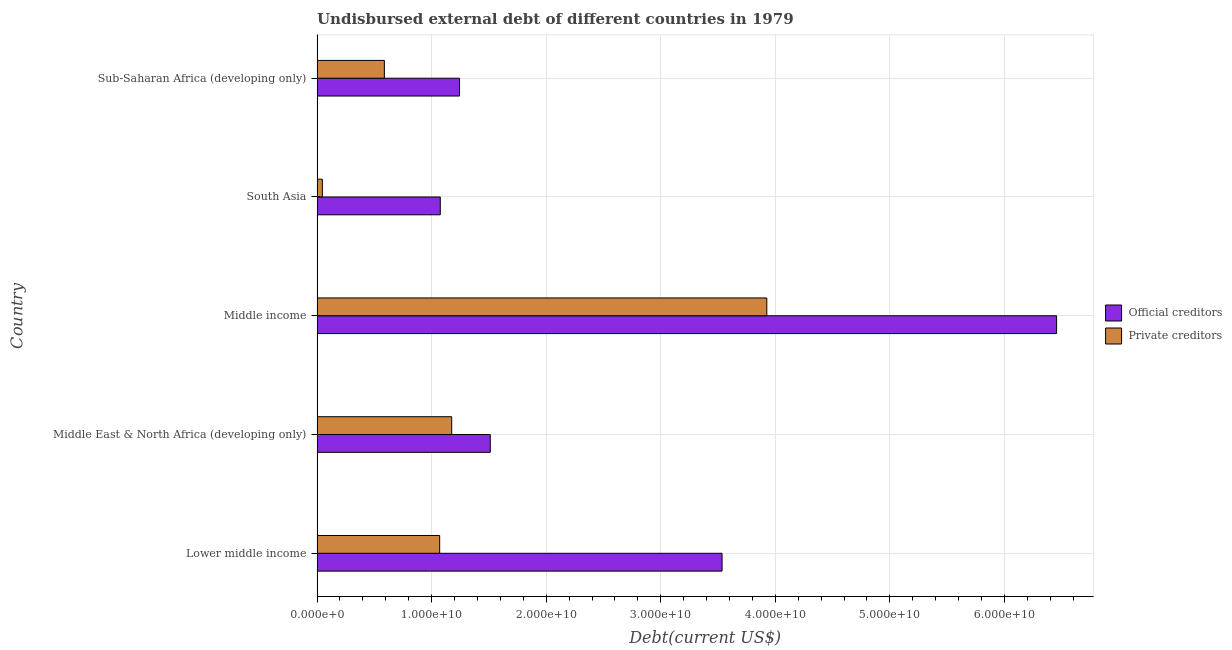How many different coloured bars are there?
Ensure brevity in your answer.  2. How many groups of bars are there?
Ensure brevity in your answer.  5. What is the label of the 1st group of bars from the top?
Your answer should be very brief. Sub-Saharan Africa (developing only). What is the undisbursed external debt of official creditors in Middle income?
Keep it short and to the point. 6.46e+1. Across all countries, what is the maximum undisbursed external debt of private creditors?
Your answer should be compact. 3.93e+1. Across all countries, what is the minimum undisbursed external debt of private creditors?
Your response must be concise. 4.63e+08. What is the total undisbursed external debt of private creditors in the graph?
Your answer should be very brief. 6.81e+1. What is the difference between the undisbursed external debt of private creditors in Lower middle income and that in South Asia?
Provide a succinct answer. 1.02e+1. What is the difference between the undisbursed external debt of private creditors in Sub-Saharan Africa (developing only) and the undisbursed external debt of official creditors in Middle East & North Africa (developing only)?
Provide a short and direct response. -9.24e+09. What is the average undisbursed external debt of private creditors per country?
Offer a very short reply. 1.36e+1. What is the difference between the undisbursed external debt of official creditors and undisbursed external debt of private creditors in Lower middle income?
Offer a very short reply. 2.46e+1. What is the ratio of the undisbursed external debt of official creditors in Middle income to that in South Asia?
Make the answer very short. 6. Is the undisbursed external debt of official creditors in Middle East & North Africa (developing only) less than that in Sub-Saharan Africa (developing only)?
Your answer should be very brief. No. What is the difference between the highest and the second highest undisbursed external debt of private creditors?
Give a very brief answer. 2.75e+1. What is the difference between the highest and the lowest undisbursed external debt of official creditors?
Offer a very short reply. 5.38e+1. In how many countries, is the undisbursed external debt of private creditors greater than the average undisbursed external debt of private creditors taken over all countries?
Keep it short and to the point. 1. Is the sum of the undisbursed external debt of official creditors in Lower middle income and Middle income greater than the maximum undisbursed external debt of private creditors across all countries?
Provide a short and direct response. Yes. What does the 2nd bar from the top in Middle East & North Africa (developing only) represents?
Your answer should be very brief. Official creditors. What does the 2nd bar from the bottom in Lower middle income represents?
Give a very brief answer. Private creditors. How many bars are there?
Give a very brief answer. 10. Are all the bars in the graph horizontal?
Your answer should be compact. Yes. Does the graph contain grids?
Your answer should be compact. Yes. Where does the legend appear in the graph?
Your answer should be very brief. Center right. How are the legend labels stacked?
Offer a very short reply. Vertical. What is the title of the graph?
Make the answer very short. Undisbursed external debt of different countries in 1979. What is the label or title of the X-axis?
Give a very brief answer. Debt(current US$). What is the Debt(current US$) of Official creditors in Lower middle income?
Offer a very short reply. 3.54e+1. What is the Debt(current US$) of Private creditors in Lower middle income?
Ensure brevity in your answer.  1.07e+1. What is the Debt(current US$) of Official creditors in Middle East & North Africa (developing only)?
Your response must be concise. 1.51e+1. What is the Debt(current US$) of Private creditors in Middle East & North Africa (developing only)?
Your answer should be very brief. 1.18e+1. What is the Debt(current US$) in Official creditors in Middle income?
Offer a very short reply. 6.46e+1. What is the Debt(current US$) in Private creditors in Middle income?
Provide a short and direct response. 3.93e+1. What is the Debt(current US$) in Official creditors in South Asia?
Provide a succinct answer. 1.08e+1. What is the Debt(current US$) of Private creditors in South Asia?
Keep it short and to the point. 4.63e+08. What is the Debt(current US$) in Official creditors in Sub-Saharan Africa (developing only)?
Give a very brief answer. 1.24e+1. What is the Debt(current US$) in Private creditors in Sub-Saharan Africa (developing only)?
Your response must be concise. 5.88e+09. Across all countries, what is the maximum Debt(current US$) in Official creditors?
Ensure brevity in your answer.  6.46e+1. Across all countries, what is the maximum Debt(current US$) in Private creditors?
Offer a terse response. 3.93e+1. Across all countries, what is the minimum Debt(current US$) of Official creditors?
Offer a terse response. 1.08e+1. Across all countries, what is the minimum Debt(current US$) of Private creditors?
Give a very brief answer. 4.63e+08. What is the total Debt(current US$) in Official creditors in the graph?
Provide a short and direct response. 1.38e+11. What is the total Debt(current US$) of Private creditors in the graph?
Keep it short and to the point. 6.81e+1. What is the difference between the Debt(current US$) of Official creditors in Lower middle income and that in Middle East & North Africa (developing only)?
Your answer should be very brief. 2.02e+1. What is the difference between the Debt(current US$) in Private creditors in Lower middle income and that in Middle East & North Africa (developing only)?
Provide a short and direct response. -1.05e+09. What is the difference between the Debt(current US$) in Official creditors in Lower middle income and that in Middle income?
Keep it short and to the point. -2.92e+1. What is the difference between the Debt(current US$) of Private creditors in Lower middle income and that in Middle income?
Offer a terse response. -2.86e+1. What is the difference between the Debt(current US$) of Official creditors in Lower middle income and that in South Asia?
Give a very brief answer. 2.46e+1. What is the difference between the Debt(current US$) of Private creditors in Lower middle income and that in South Asia?
Keep it short and to the point. 1.02e+1. What is the difference between the Debt(current US$) of Official creditors in Lower middle income and that in Sub-Saharan Africa (developing only)?
Offer a very short reply. 2.29e+1. What is the difference between the Debt(current US$) in Private creditors in Lower middle income and that in Sub-Saharan Africa (developing only)?
Your answer should be compact. 4.83e+09. What is the difference between the Debt(current US$) of Official creditors in Middle East & North Africa (developing only) and that in Middle income?
Offer a very short reply. -4.94e+1. What is the difference between the Debt(current US$) of Private creditors in Middle East & North Africa (developing only) and that in Middle income?
Your response must be concise. -2.75e+1. What is the difference between the Debt(current US$) of Official creditors in Middle East & North Africa (developing only) and that in South Asia?
Provide a succinct answer. 4.36e+09. What is the difference between the Debt(current US$) in Private creditors in Middle East & North Africa (developing only) and that in South Asia?
Offer a terse response. 1.13e+1. What is the difference between the Debt(current US$) in Official creditors in Middle East & North Africa (developing only) and that in Sub-Saharan Africa (developing only)?
Your response must be concise. 2.68e+09. What is the difference between the Debt(current US$) of Private creditors in Middle East & North Africa (developing only) and that in Sub-Saharan Africa (developing only)?
Your response must be concise. 5.88e+09. What is the difference between the Debt(current US$) in Official creditors in Middle income and that in South Asia?
Offer a terse response. 5.38e+1. What is the difference between the Debt(current US$) of Private creditors in Middle income and that in South Asia?
Provide a succinct answer. 3.88e+1. What is the difference between the Debt(current US$) of Official creditors in Middle income and that in Sub-Saharan Africa (developing only)?
Make the answer very short. 5.21e+1. What is the difference between the Debt(current US$) of Private creditors in Middle income and that in Sub-Saharan Africa (developing only)?
Offer a very short reply. 3.34e+1. What is the difference between the Debt(current US$) of Official creditors in South Asia and that in Sub-Saharan Africa (developing only)?
Your answer should be compact. -1.68e+09. What is the difference between the Debt(current US$) in Private creditors in South Asia and that in Sub-Saharan Africa (developing only)?
Offer a terse response. -5.41e+09. What is the difference between the Debt(current US$) of Official creditors in Lower middle income and the Debt(current US$) of Private creditors in Middle East & North Africa (developing only)?
Your answer should be compact. 2.36e+1. What is the difference between the Debt(current US$) in Official creditors in Lower middle income and the Debt(current US$) in Private creditors in Middle income?
Provide a succinct answer. -3.91e+09. What is the difference between the Debt(current US$) in Official creditors in Lower middle income and the Debt(current US$) in Private creditors in South Asia?
Provide a short and direct response. 3.49e+1. What is the difference between the Debt(current US$) in Official creditors in Lower middle income and the Debt(current US$) in Private creditors in Sub-Saharan Africa (developing only)?
Keep it short and to the point. 2.95e+1. What is the difference between the Debt(current US$) in Official creditors in Middle East & North Africa (developing only) and the Debt(current US$) in Private creditors in Middle income?
Offer a very short reply. -2.41e+1. What is the difference between the Debt(current US$) of Official creditors in Middle East & North Africa (developing only) and the Debt(current US$) of Private creditors in South Asia?
Your response must be concise. 1.47e+1. What is the difference between the Debt(current US$) in Official creditors in Middle East & North Africa (developing only) and the Debt(current US$) in Private creditors in Sub-Saharan Africa (developing only)?
Make the answer very short. 9.24e+09. What is the difference between the Debt(current US$) in Official creditors in Middle income and the Debt(current US$) in Private creditors in South Asia?
Give a very brief answer. 6.41e+1. What is the difference between the Debt(current US$) in Official creditors in Middle income and the Debt(current US$) in Private creditors in Sub-Saharan Africa (developing only)?
Offer a terse response. 5.87e+1. What is the difference between the Debt(current US$) of Official creditors in South Asia and the Debt(current US$) of Private creditors in Sub-Saharan Africa (developing only)?
Make the answer very short. 4.88e+09. What is the average Debt(current US$) in Official creditors per country?
Offer a very short reply. 2.76e+1. What is the average Debt(current US$) in Private creditors per country?
Make the answer very short. 1.36e+1. What is the difference between the Debt(current US$) of Official creditors and Debt(current US$) of Private creditors in Lower middle income?
Your answer should be compact. 2.46e+1. What is the difference between the Debt(current US$) in Official creditors and Debt(current US$) in Private creditors in Middle East & North Africa (developing only)?
Make the answer very short. 3.37e+09. What is the difference between the Debt(current US$) in Official creditors and Debt(current US$) in Private creditors in Middle income?
Your answer should be compact. 2.53e+1. What is the difference between the Debt(current US$) of Official creditors and Debt(current US$) of Private creditors in South Asia?
Give a very brief answer. 1.03e+1. What is the difference between the Debt(current US$) in Official creditors and Debt(current US$) in Private creditors in Sub-Saharan Africa (developing only)?
Your answer should be compact. 6.56e+09. What is the ratio of the Debt(current US$) in Official creditors in Lower middle income to that in Middle East & North Africa (developing only)?
Your answer should be compact. 2.34. What is the ratio of the Debt(current US$) in Private creditors in Lower middle income to that in Middle East & North Africa (developing only)?
Offer a very short reply. 0.91. What is the ratio of the Debt(current US$) of Official creditors in Lower middle income to that in Middle income?
Your answer should be very brief. 0.55. What is the ratio of the Debt(current US$) in Private creditors in Lower middle income to that in Middle income?
Ensure brevity in your answer.  0.27. What is the ratio of the Debt(current US$) in Official creditors in Lower middle income to that in South Asia?
Keep it short and to the point. 3.29. What is the ratio of the Debt(current US$) in Private creditors in Lower middle income to that in South Asia?
Provide a succinct answer. 23.11. What is the ratio of the Debt(current US$) of Official creditors in Lower middle income to that in Sub-Saharan Africa (developing only)?
Offer a terse response. 2.84. What is the ratio of the Debt(current US$) in Private creditors in Lower middle income to that in Sub-Saharan Africa (developing only)?
Your answer should be very brief. 1.82. What is the ratio of the Debt(current US$) in Official creditors in Middle East & North Africa (developing only) to that in Middle income?
Your response must be concise. 0.23. What is the ratio of the Debt(current US$) in Private creditors in Middle East & North Africa (developing only) to that in Middle income?
Your answer should be very brief. 0.3. What is the ratio of the Debt(current US$) of Official creditors in Middle East & North Africa (developing only) to that in South Asia?
Your response must be concise. 1.41. What is the ratio of the Debt(current US$) in Private creditors in Middle East & North Africa (developing only) to that in South Asia?
Your response must be concise. 25.37. What is the ratio of the Debt(current US$) in Official creditors in Middle East & North Africa (developing only) to that in Sub-Saharan Africa (developing only)?
Your answer should be compact. 1.22. What is the ratio of the Debt(current US$) of Private creditors in Middle East & North Africa (developing only) to that in Sub-Saharan Africa (developing only)?
Make the answer very short. 2. What is the ratio of the Debt(current US$) of Official creditors in Middle income to that in South Asia?
Offer a very short reply. 6. What is the ratio of the Debt(current US$) of Private creditors in Middle income to that in South Asia?
Provide a succinct answer. 84.75. What is the ratio of the Debt(current US$) of Official creditors in Middle income to that in Sub-Saharan Africa (developing only)?
Offer a terse response. 5.19. What is the ratio of the Debt(current US$) in Private creditors in Middle income to that in Sub-Saharan Africa (developing only)?
Give a very brief answer. 6.68. What is the ratio of the Debt(current US$) of Official creditors in South Asia to that in Sub-Saharan Africa (developing only)?
Your answer should be very brief. 0.86. What is the ratio of the Debt(current US$) of Private creditors in South Asia to that in Sub-Saharan Africa (developing only)?
Keep it short and to the point. 0.08. What is the difference between the highest and the second highest Debt(current US$) of Official creditors?
Your answer should be very brief. 2.92e+1. What is the difference between the highest and the second highest Debt(current US$) in Private creditors?
Keep it short and to the point. 2.75e+1. What is the difference between the highest and the lowest Debt(current US$) of Official creditors?
Offer a very short reply. 5.38e+1. What is the difference between the highest and the lowest Debt(current US$) in Private creditors?
Make the answer very short. 3.88e+1. 